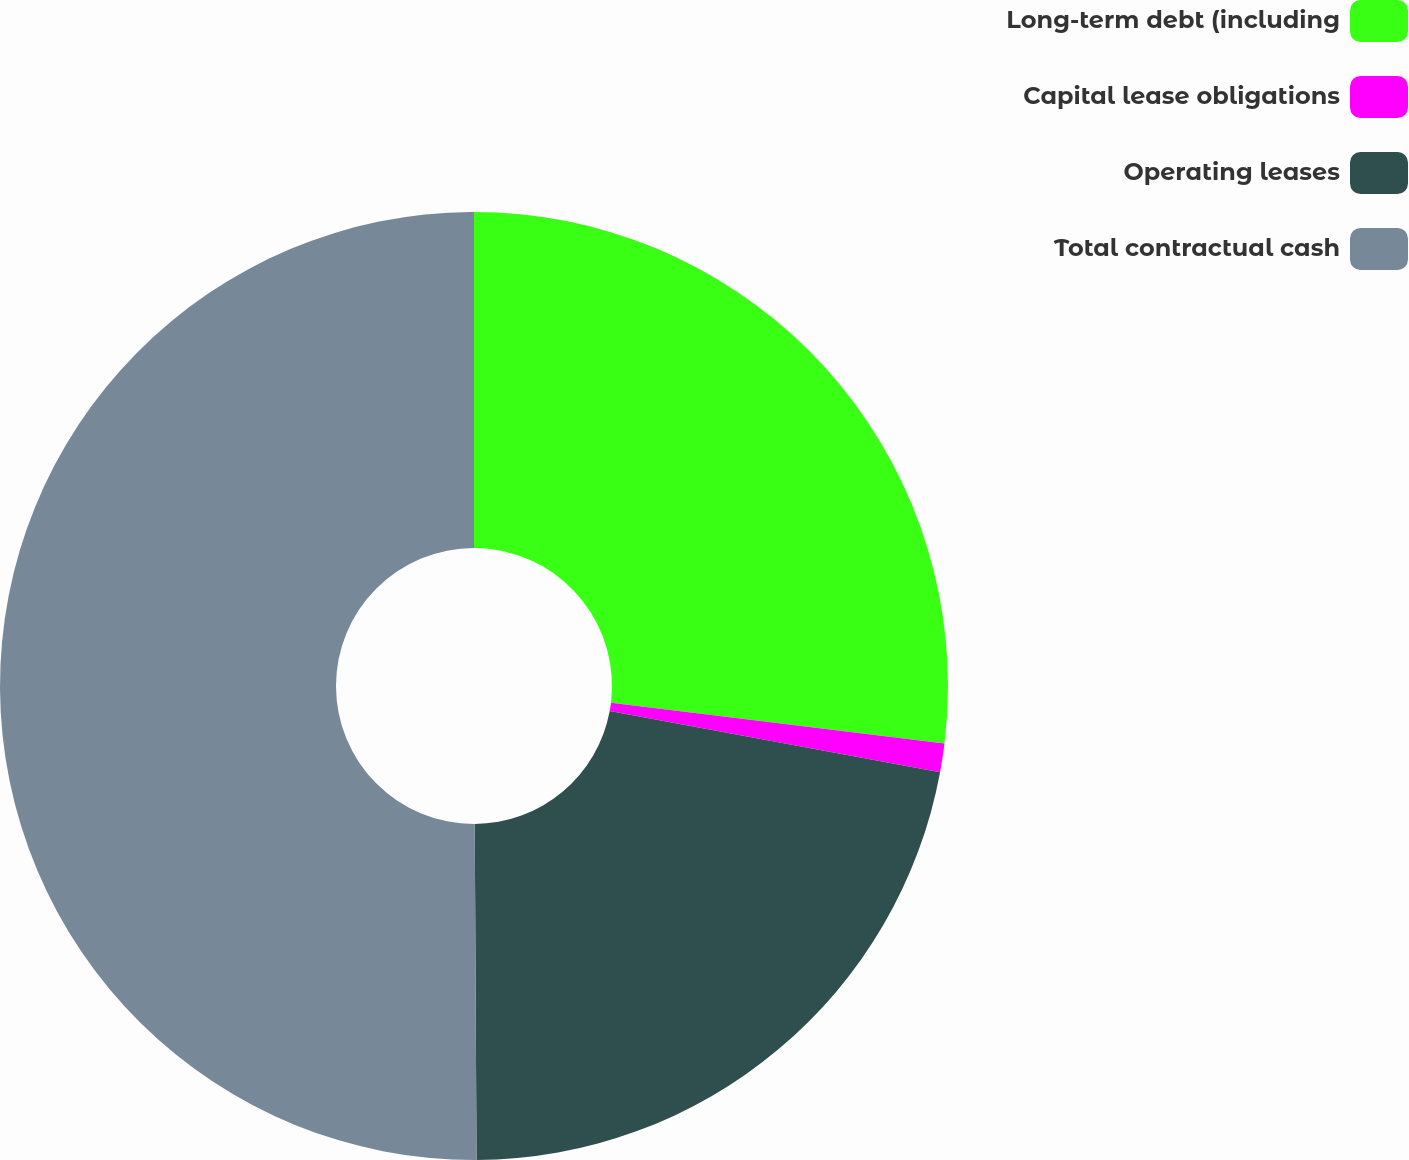Convert chart. <chart><loc_0><loc_0><loc_500><loc_500><pie_chart><fcel>Long-term debt (including<fcel>Capital lease obligations<fcel>Operating leases<fcel>Total contractual cash<nl><fcel>26.93%<fcel>0.98%<fcel>22.0%<fcel>50.08%<nl></chart> 